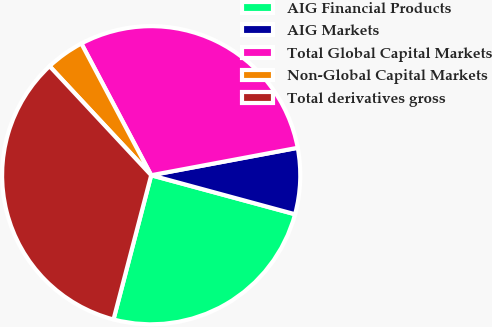<chart> <loc_0><loc_0><loc_500><loc_500><pie_chart><fcel>AIG Financial Products<fcel>AIG Markets<fcel>Total Global Capital Markets<fcel>Non-Global Capital Markets<fcel>Total derivatives gross<nl><fcel>24.85%<fcel>7.16%<fcel>29.81%<fcel>4.18%<fcel>33.99%<nl></chart> 